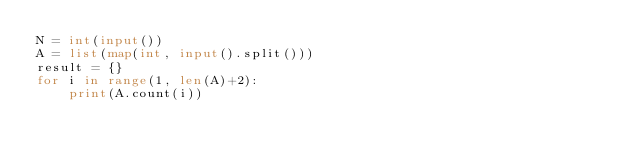<code> <loc_0><loc_0><loc_500><loc_500><_Python_>N = int(input())
A = list(map(int, input().split()))
result = {}
for i in range(1, len(A)+2):
    print(A.count(i))
</code> 